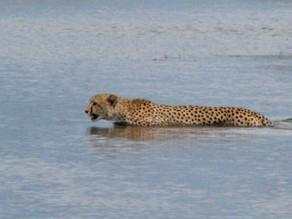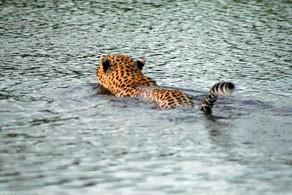The first image is the image on the left, the second image is the image on the right. Evaluate the accuracy of this statement regarding the images: "The left image has a cheetah that is approaching the shore.". Is it true? Answer yes or no. No. 